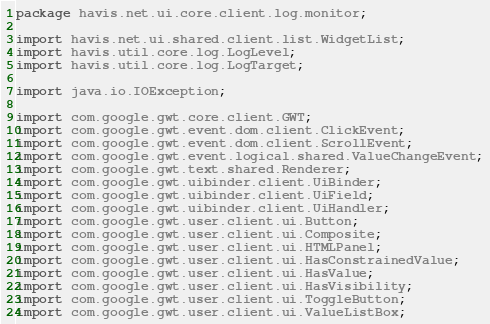<code> <loc_0><loc_0><loc_500><loc_500><_Java_>package havis.net.ui.core.client.log.monitor;

import havis.net.ui.shared.client.list.WidgetList;
import havis.util.core.log.LogLevel;
import havis.util.core.log.LogTarget;

import java.io.IOException;

import com.google.gwt.core.client.GWT;
import com.google.gwt.event.dom.client.ClickEvent;
import com.google.gwt.event.dom.client.ScrollEvent;
import com.google.gwt.event.logical.shared.ValueChangeEvent;
import com.google.gwt.text.shared.Renderer;
import com.google.gwt.uibinder.client.UiBinder;
import com.google.gwt.uibinder.client.UiField;
import com.google.gwt.uibinder.client.UiHandler;
import com.google.gwt.user.client.ui.Button;
import com.google.gwt.user.client.ui.Composite;
import com.google.gwt.user.client.ui.HTMLPanel;
import com.google.gwt.user.client.ui.HasConstrainedValue;
import com.google.gwt.user.client.ui.HasValue;
import com.google.gwt.user.client.ui.HasVisibility;
import com.google.gwt.user.client.ui.ToggleButton;
import com.google.gwt.user.client.ui.ValueListBox;</code> 